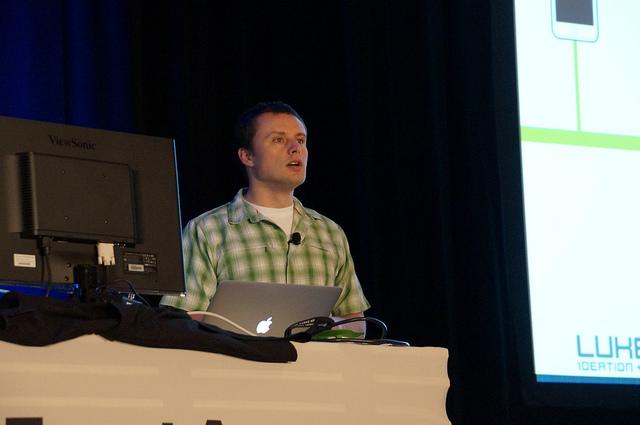Is he making a presentation?
Answer briefly. Yes. What I kind of computer is he using?
Quick response, please. Apple. Where is the laptop?
Concise answer only. Table. What is the boy doing?
Keep it brief. Speaking. How many microphones do you see?
Give a very brief answer. 1. What is the man demonstrating?
Write a very short answer. Technology. 